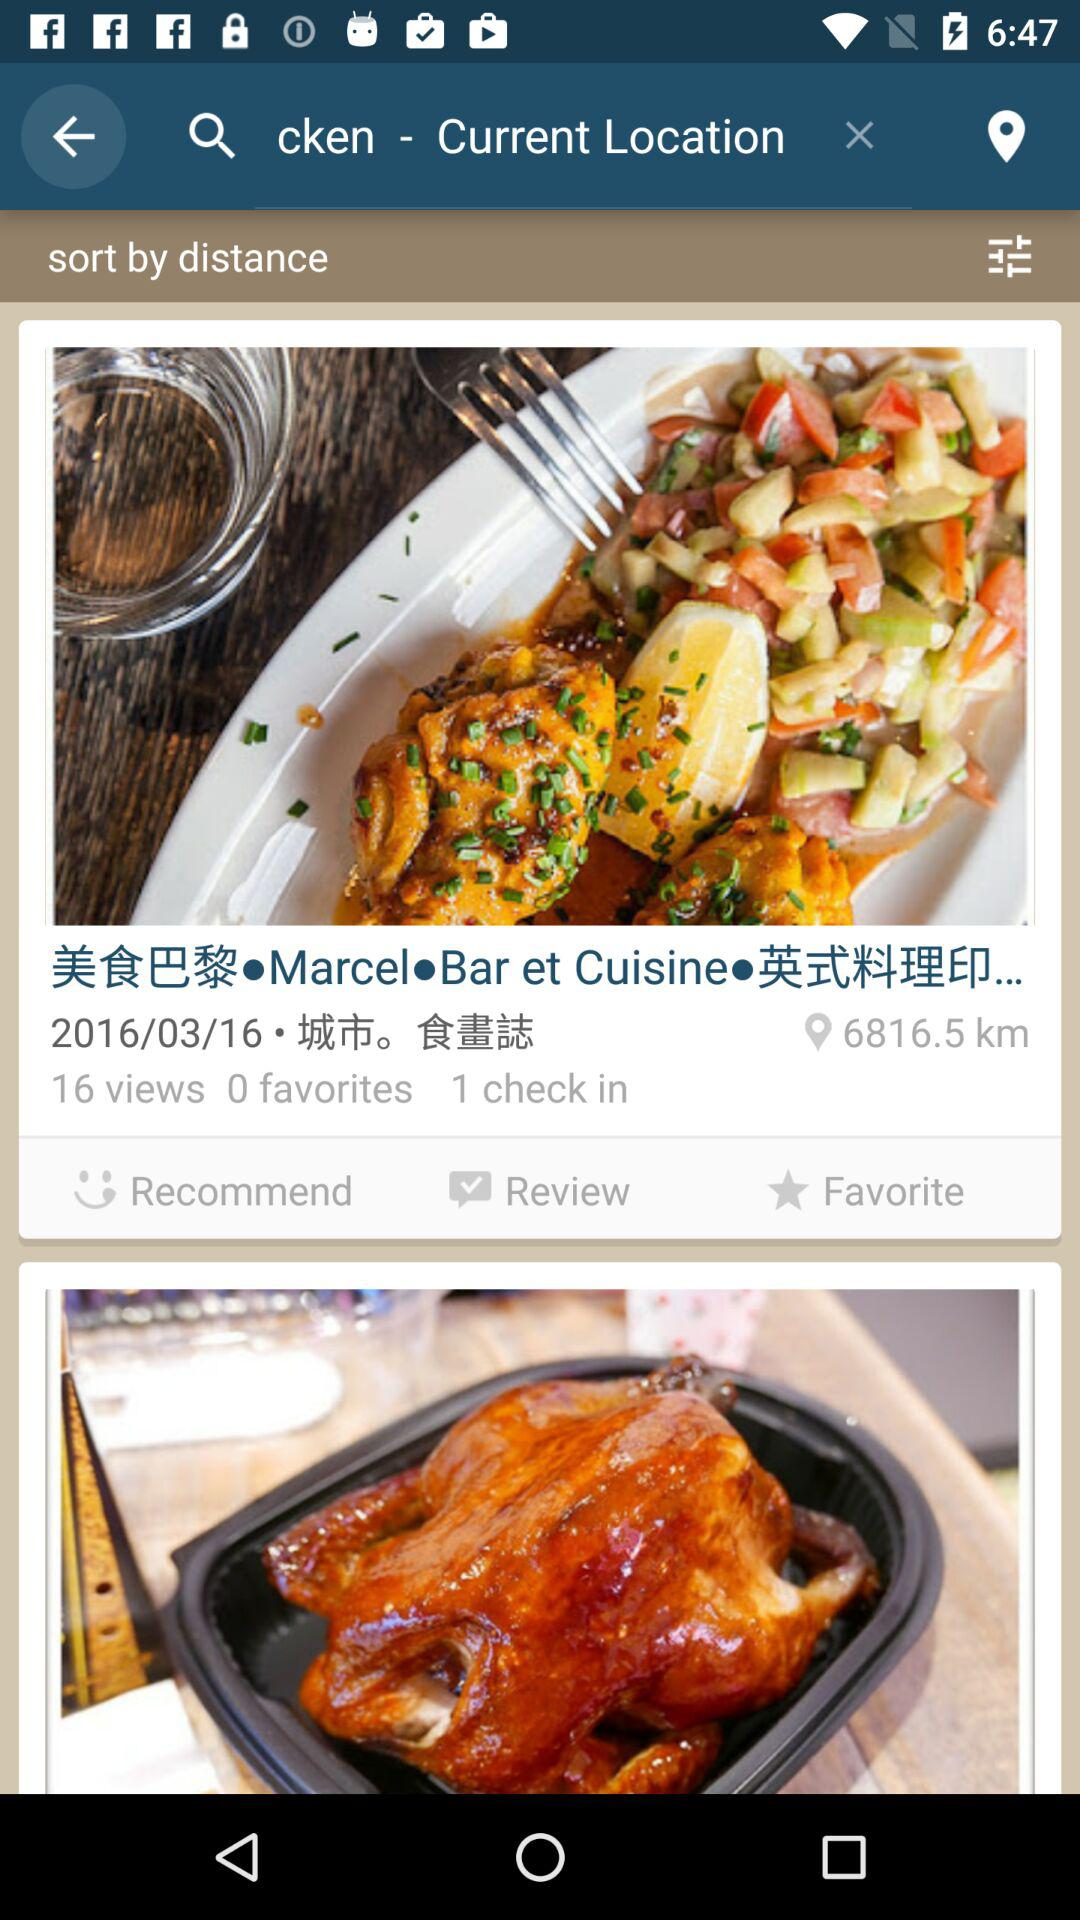How many people have marked the restaurant as a favorite? The number of people is 0. 